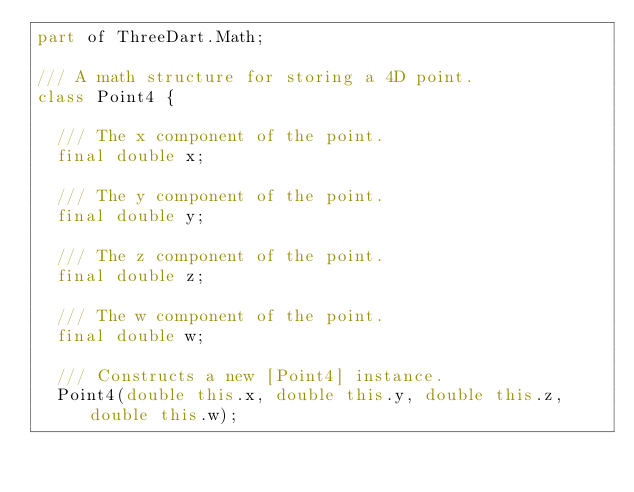Convert code to text. <code><loc_0><loc_0><loc_500><loc_500><_Dart_>part of ThreeDart.Math;

/// A math structure for storing a 4D point.
class Point4 {

  /// The x component of the point.
  final double x;

  /// The y component of the point.
  final double y;

  /// The z component of the point.
  final double z;

  /// The w component of the point.
  final double w;

  /// Constructs a new [Point4] instance.
  Point4(double this.x, double this.y, double this.z, double this.w);
</code> 